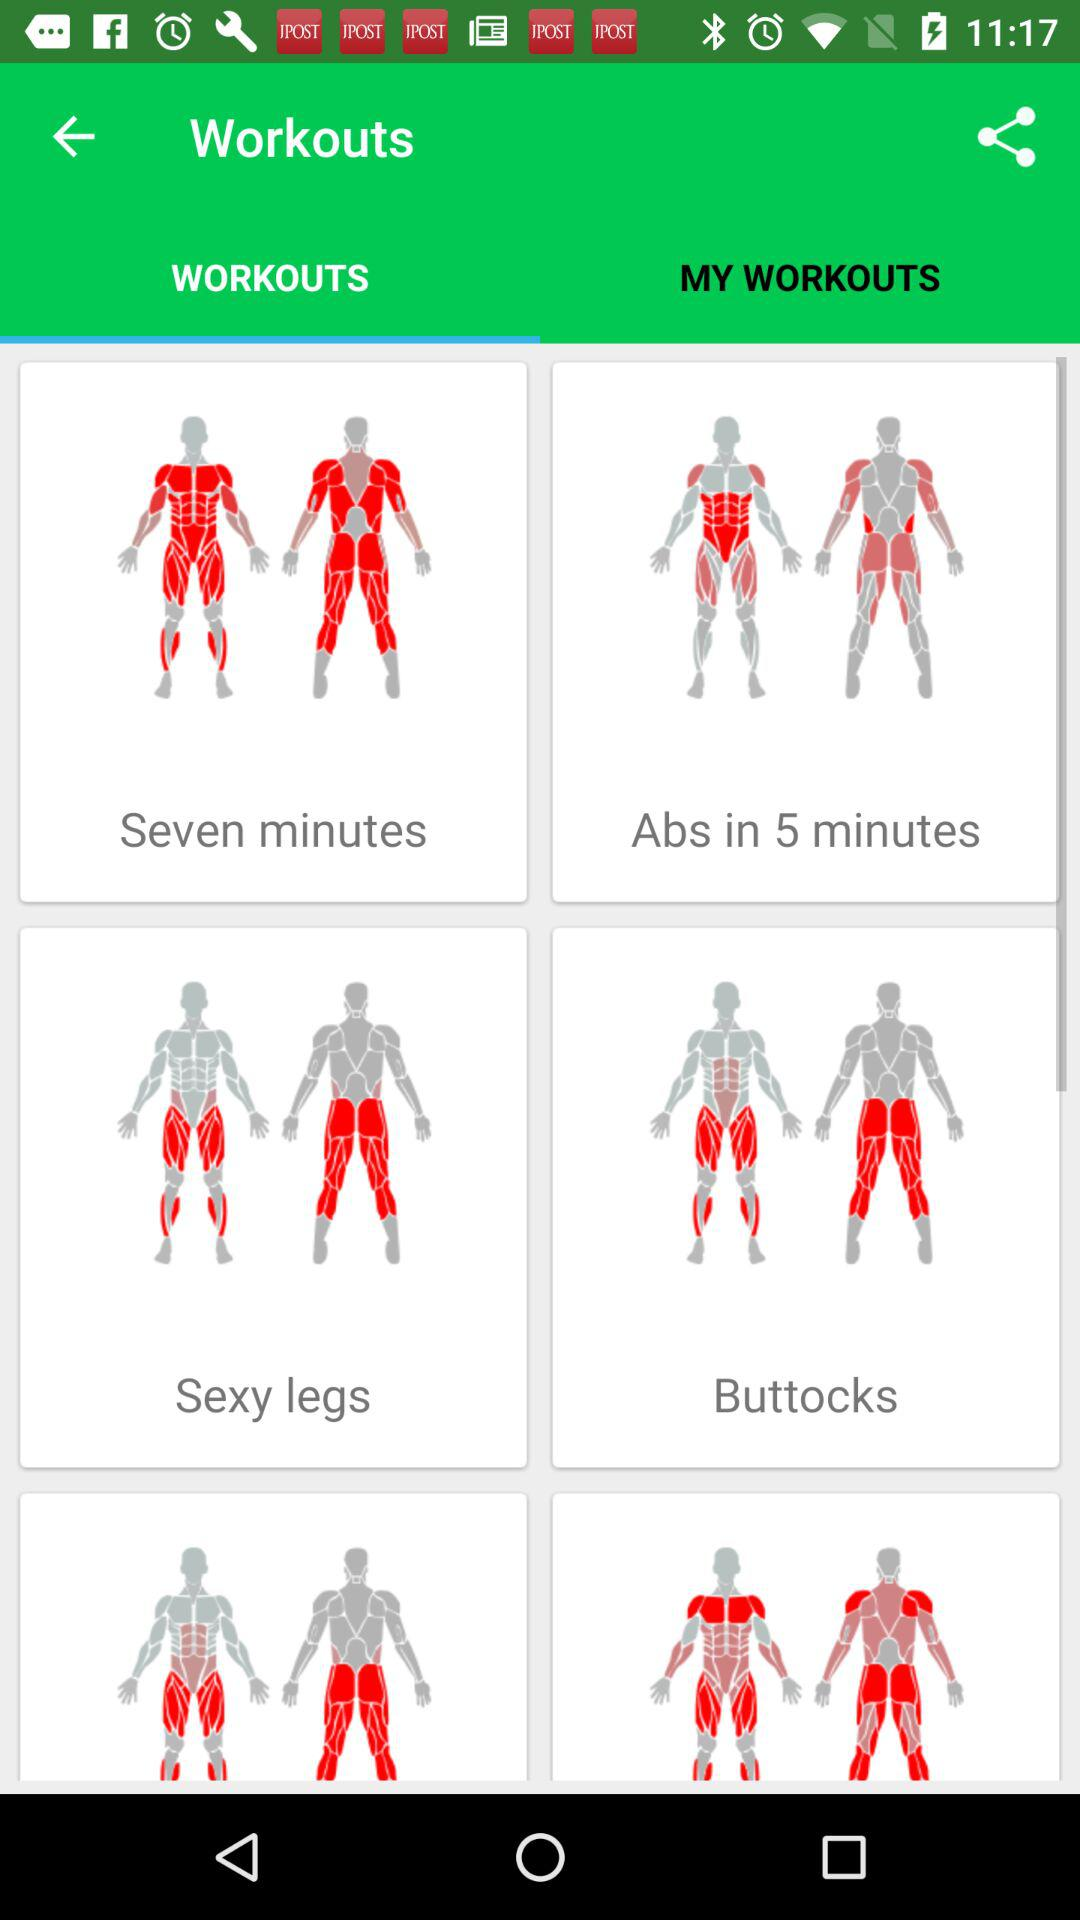Which tab am I on? You are on the "WORKOUTS" tab. 